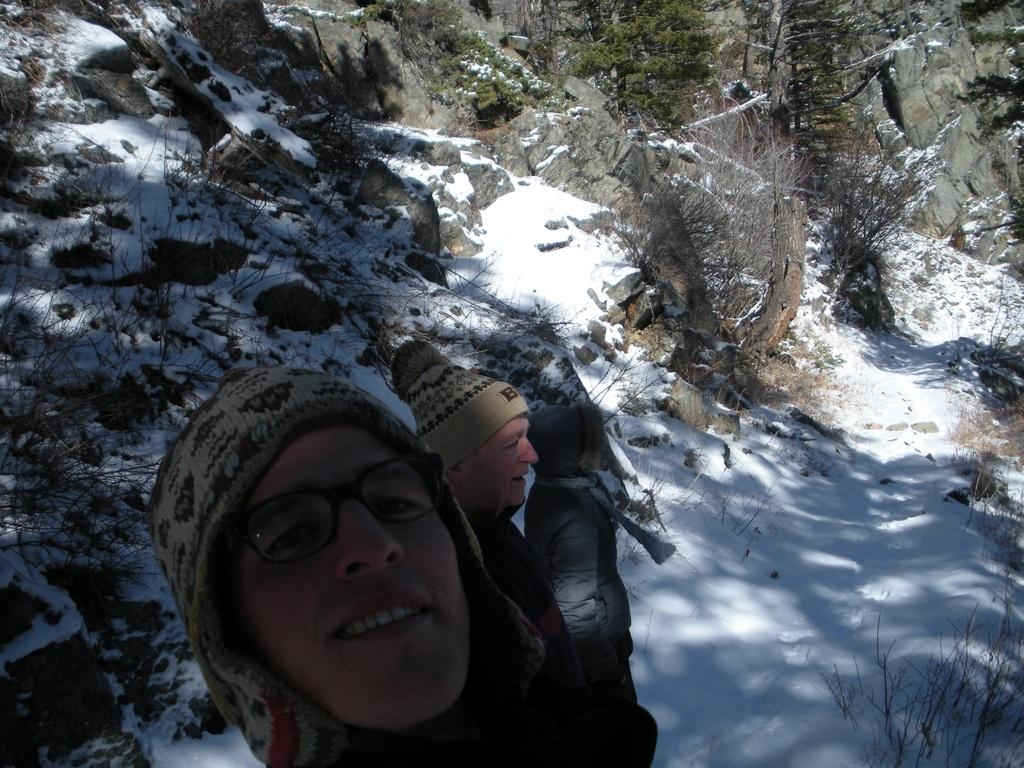How many people are in the image? There are three persons standing at the bottom of the image. What are the people wearing in the image? The persons are wearing jackets and caps. What can be seen in the background of the image? There are hills, trees, and snow visible in the background of the image. What type of straw is being used by the person in the image? There is no straw present in the image. 